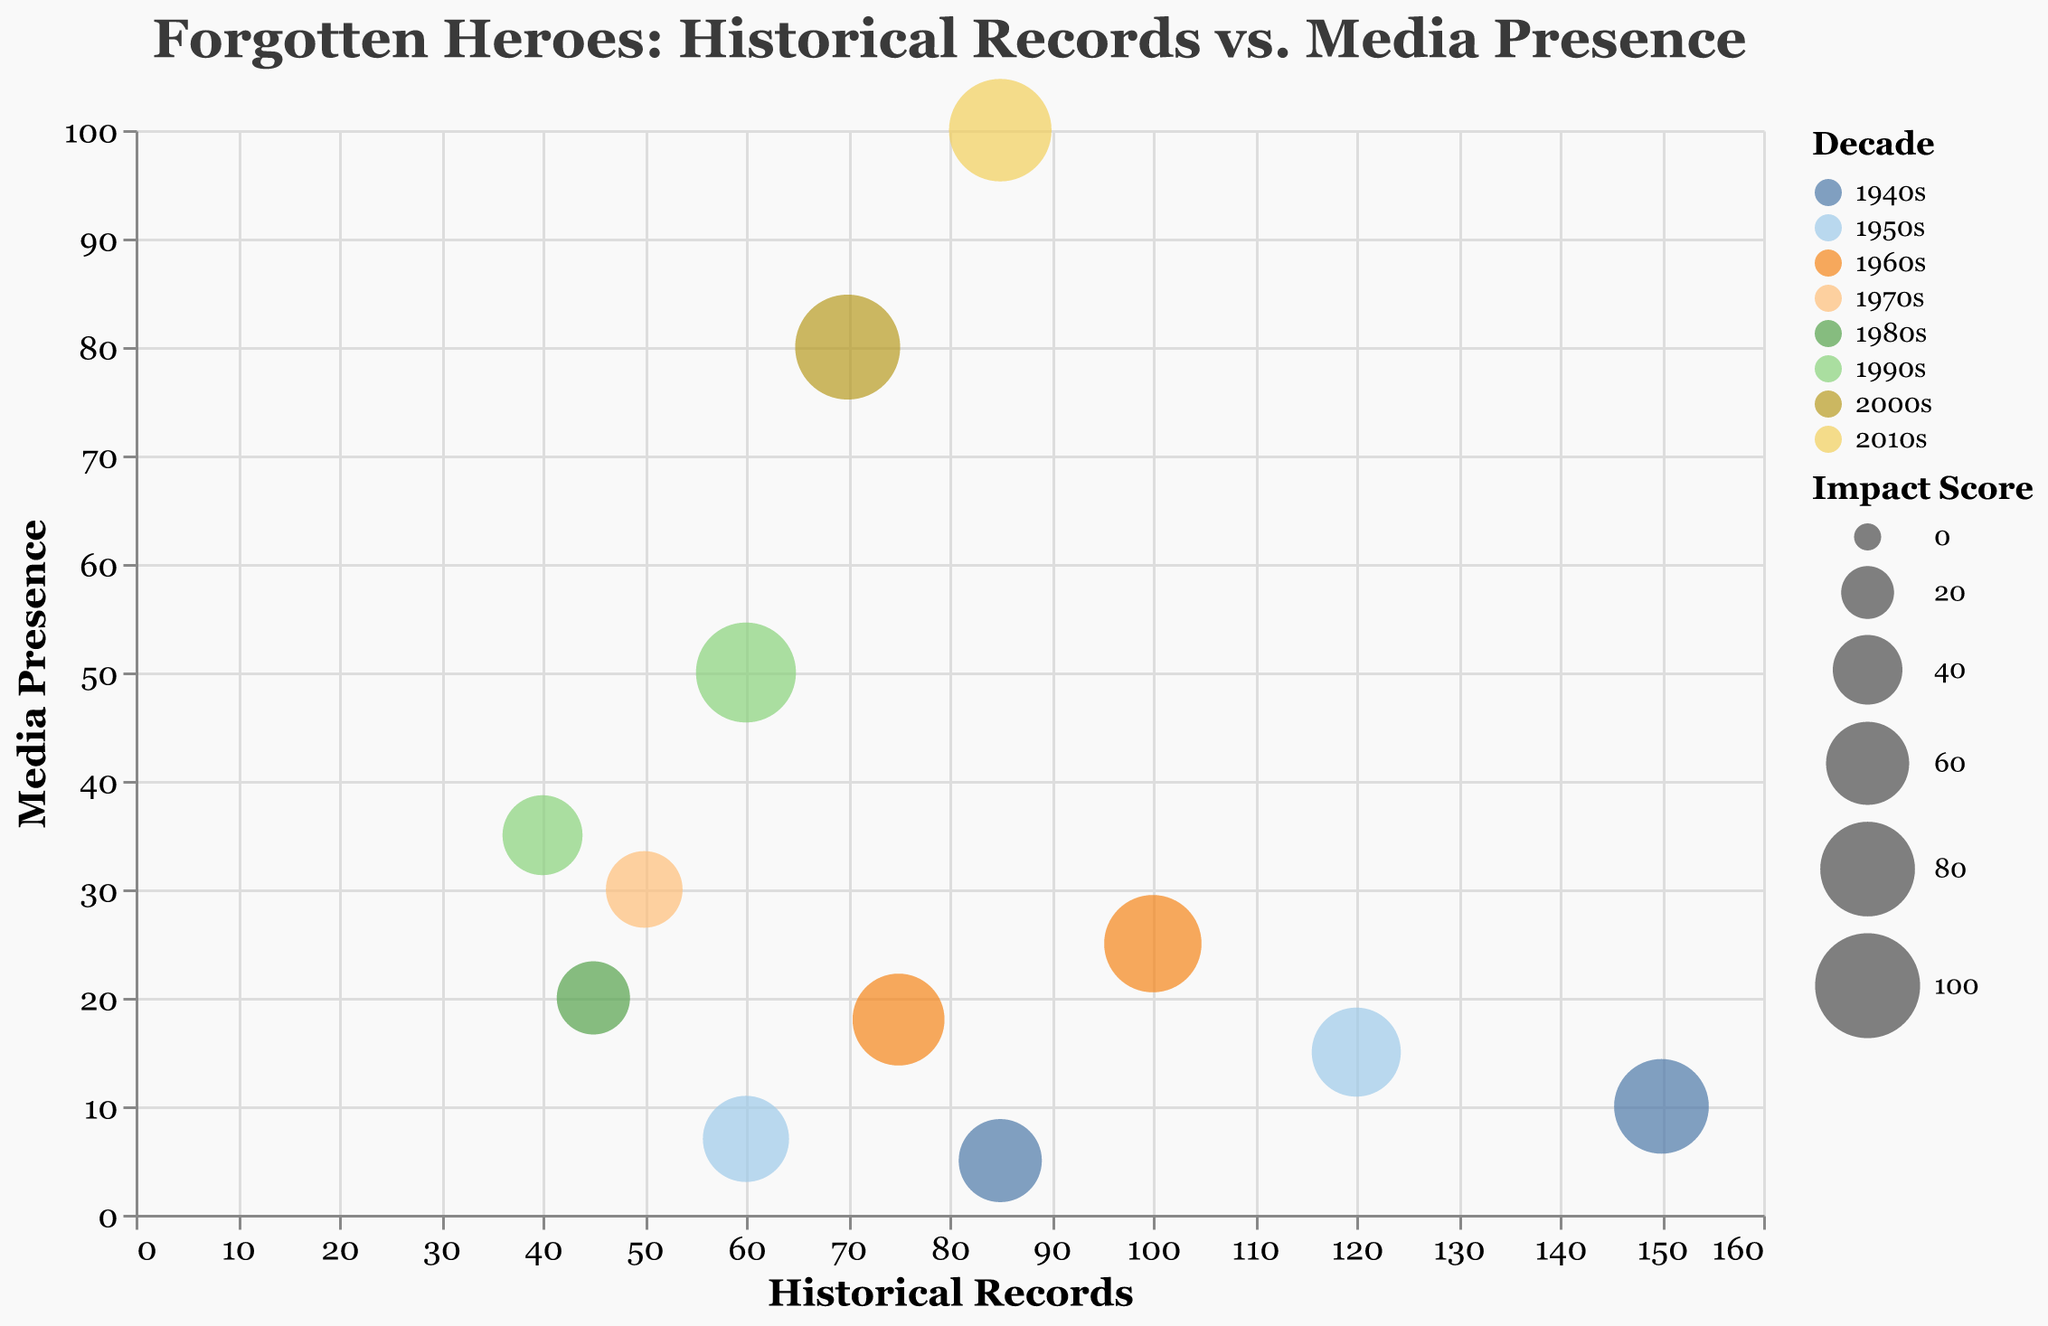How many data points are shown for the 1950s? To find the number of data points for the 1950s, look for all circles that are colored the same and belong to the 1950s. There are two such points indicating John Basilone and Andrée de Jongh.
Answer: 2 Which hero from the 2000s has the highest media presence? To determine this, look for the data points from the 2000s and compare their values on the y-axis, which represents media presence. The hero with the highest media presence in the 2000s is Louis Zamperini, with a media presence of 80 articles.
Answer: Louis Zamperini What is the impact score for Nancy Wake, and which decade does she belong to? Identify the bubble that corresponds to Nancy Wake using the tooltip feature. The tooltip shows that Nancy Wake has an impact score of 85 and belongs to the 1960s.
Answer: Impact score: 85, Decade: 1960s Compare the number of historical records between Richard Winters and Harriet Tubman. Who has more, and by how much? Check the historical records for both heroes: Richard Winters (150) and Harriet Tubman (85). Subtract Harriet Tubman's records from Richard Winters' to get the difference: 150 - 85 = 65.
Answer: Richard Winters has 65 more records What is the average impact score for the heroes from the 1990s? Identify the heroes from the 1990s (Audie Murphy and Simo Häyhä) and add their impact scores: 90 + 55 = 145. Divide this by the number of heroes (2) to find the average: 145 / 2 = 72.5.
Answer: 72.5 How does Louis Zamperini's media presence compare to Nancy Wake's? Look at the media presence of Louis Zamperini (80 articles) and Nancy Wake (25 articles). Louis Zamperini has more media presence.
Answer: Louis Zamperini has more What hero has the smallest impact score, and what is that score? Check the bubble sizes to see which hero has the smallest one. Andrey Vlasov has the smallest impact score of 45.
Answer: Andrey Vlasov, 45 Identify the hero with the highest historical records in the same decade, and compare their impact score with Desmond Doss. Identify Decades and compare the impact score from the same decades. Desmond Doss has an impact score of 75. In the 1960s, Nancy Wake has a higher score of 85.
Answer: Nancy Wake, higher score Which decade shows the highest overall media presence? To find the decade with the highest overall media presence, sum the media presence for each decade and compare. The 2010s have the highest presence with 100 articles for Noor Inayat Khan.
Answer: 2010s Determine the decade with the least number of historical records on average per hero. To determine this, calculate the average number of historical records for each decade. The 1970s have only one hero Maurice Rose with a historical record count of 50.
Answer: 1970s 